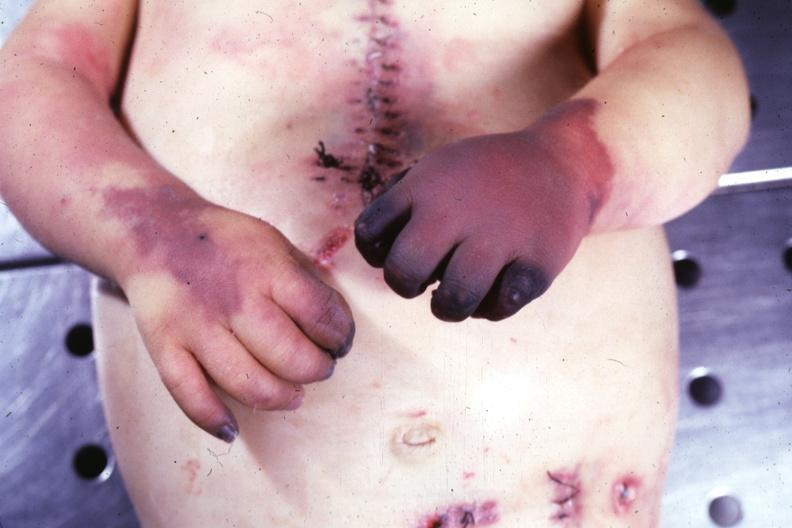what does this image show?
Answer the question using a single word or phrase. Gangrene both hands due to embolism case of av canal with downs syndrome 